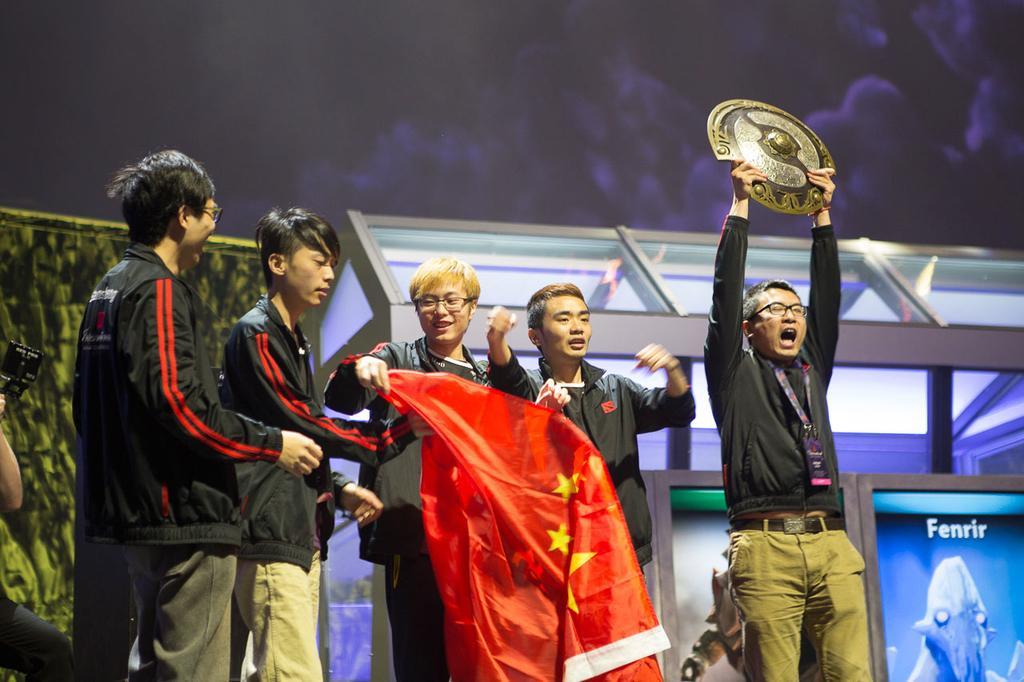Could you give a brief overview of what you see in this image? In the picture we can see five people are standing and four of them are holding a flag cloth which is red in color and one man is holding a shield, raising it up and he is with a black color shirt and in the background we can see a hut type of construction with glasses in it and behind it we can see a screen. 